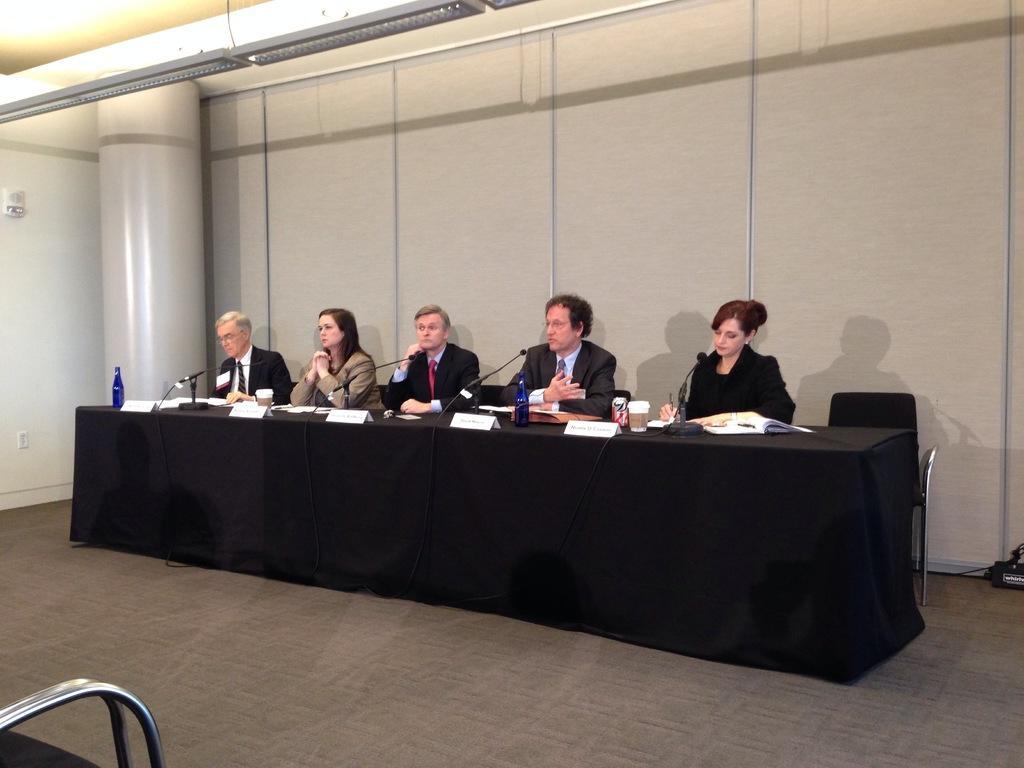Describe this image in one or two sentences. In this picture we can see three men and two woman sitting on chair and in front of them there is table and on table we can see bottles, mic, glasses, name boards, books and in background we can see wall, pillar, lights. 